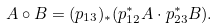Convert formula to latex. <formula><loc_0><loc_0><loc_500><loc_500>A \circ B = ( p _ { 1 3 } ) _ { * } ( p _ { 1 2 } ^ { * } A \cdot p _ { 2 3 } ^ { * } B ) .</formula> 